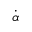<formula> <loc_0><loc_0><loc_500><loc_500>\dot { \alpha }</formula> 